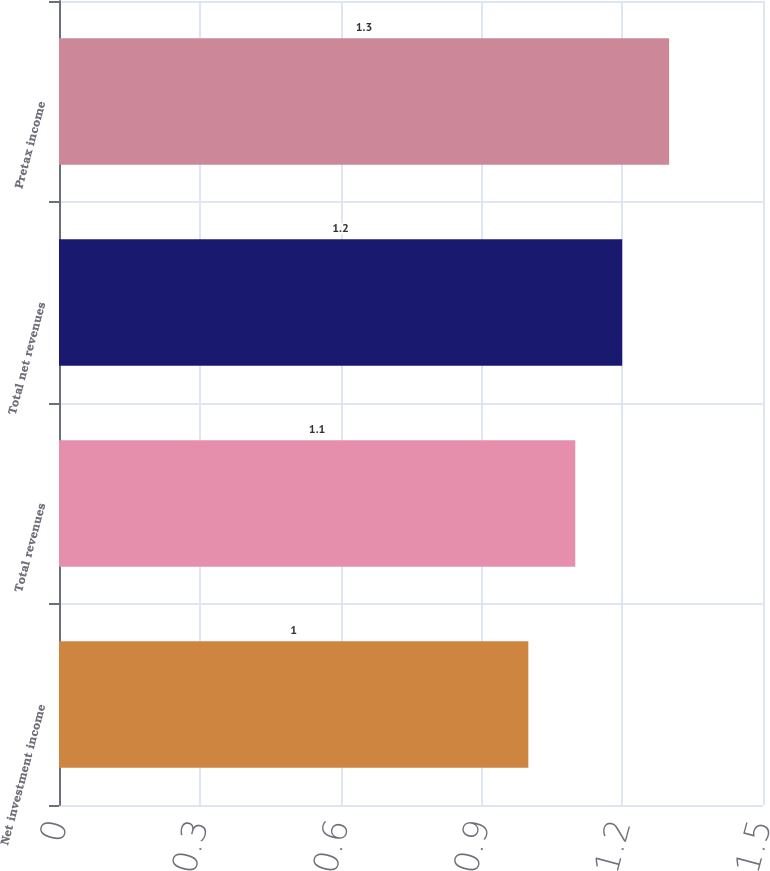<chart> <loc_0><loc_0><loc_500><loc_500><bar_chart><fcel>Net investment income<fcel>Total revenues<fcel>Total net revenues<fcel>Pretax income<nl><fcel>1<fcel>1.1<fcel>1.2<fcel>1.3<nl></chart> 